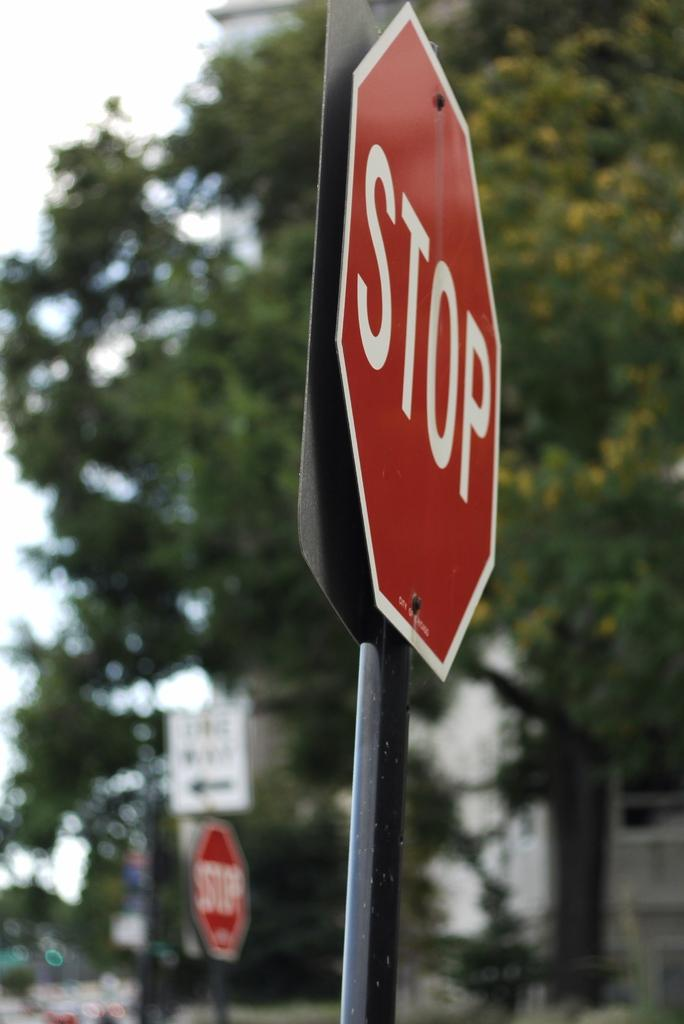<image>
Present a compact description of the photo's key features. a sign that says the word stop on it outside 